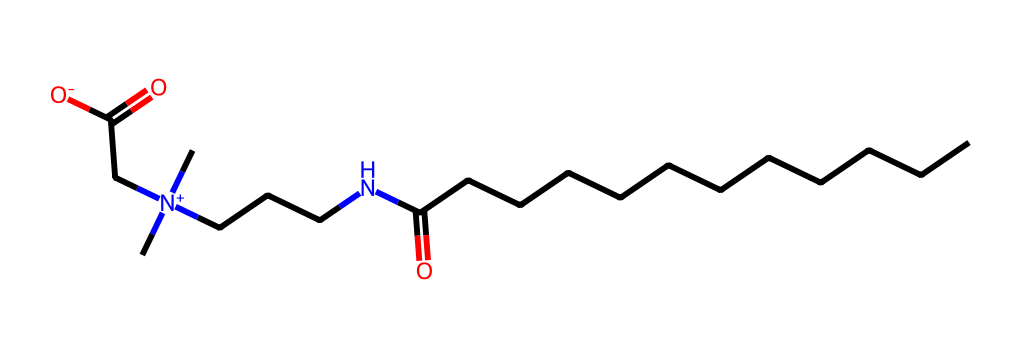What is the main functional group present in cocamidopropyl betaine? The presence of the nitrogen atom bonded to both hydrocarbon chains and carboxylic acid functional groups identifies the quaternary ammonium group as the main functional group in cocamidopropyl betaine.
Answer: quaternary ammonium group How many carbon atoms are present in cocamidopropyl betaine? By analyzing the molecular structure, there is a long carbon chain which consists of 12 carbon atoms in the hydrocarbon portion and another 2 in the amine and carboxylic sections, totaling 14 carbon atoms.
Answer: 14 What type of chemical is cocamidopropyl betaine classified as? The structure shows that it has both hydrophilic (water-attracting) and hydrophobic (water-repelling) regions, indicating that it acts as a surfactant, particularly as an amphoteric surfactant.
Answer: surfactant How many nitrogen atoms are in cocamidopropyl betaine? The structure has one nitrogen atom that is part of the quaternary ammonium functional group, indicating that there’s one nitrogen present in the molecule.
Answer: 1 What type of surfactant is cocamidopropyl betaine primarily considered? Its structure shows it carries both positive and neutral charges depending on pH conditions, making it amphoteric, which is characteristic of cocamidopropyl betaine being an amphoteric surfactant.
Answer: amphoteric 